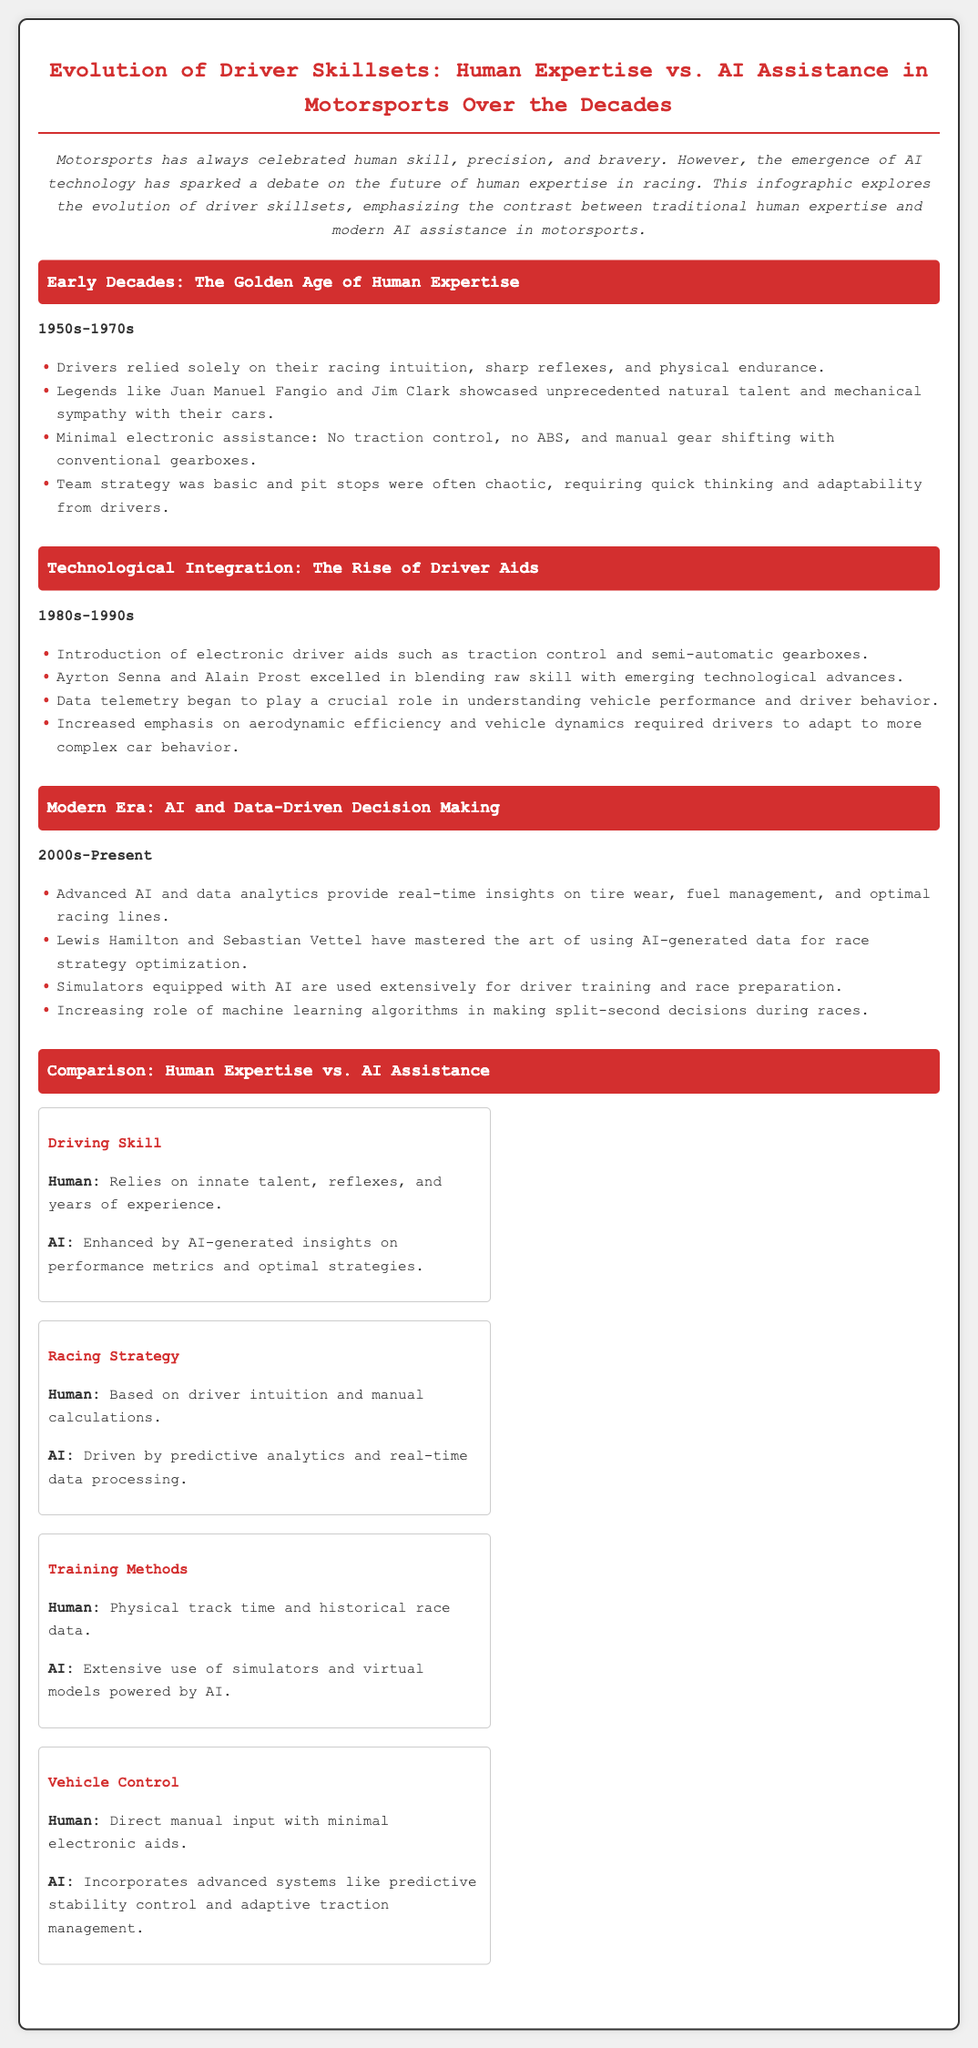What years are considered the early decades of human expertise in motorsports? The document states that the early decades refer to the 1950s-1970s.
Answer: 1950s-1970s Who were highlighted as legends during the early decades? The infographic mentions Juan Manuel Fangio and Jim Clark as legendary drivers.
Answer: Juan Manuel Fangio and Jim Clark What technological advancement began to be introduced in the 1980s-1990s? The document notes the introduction of electronic driver aids such as traction control and semi-automatic gearboxes.
Answer: Electronic driver aids Which drivers are mentioned as mastering the use of AI-generated data? The text highlights Lewis Hamilton and Sebastian Vettel in the context of AI utilization in races.
Answer: Lewis Hamilton and Sebastian Vettel What is the main difference in driving skill between human expertise and AI assistance? The document explains that human expertise relies on innate talent, while AI assistance enhances insights on performance metrics.
Answer: Innate talent vs. AI-generated insights What period marks the modern era of AI and data-driven decision making in motorsports? The infographic specifies that the modern era spans from the 2000s to the present.
Answer: 2000s-Present During which decades did racing strategy transition from intuition to data processing? The comparison chart illustrates this transition occurring during the 2000s-Present era.
Answer: 2000s-Present What was the focus of training methods in the earlier decades compared to modern approaches? The document states that early methods focused on physical track time, while modern methods extensively use simulators.
Answer: Physical track time vs. simulators Which aspect of vehicle control is more reliant on technology in the modern era compared to human expertise? The document differentiates that AI assistance incorporates advanced systems like predictive stability control in vehicle control.
Answer: Predictive stability control 